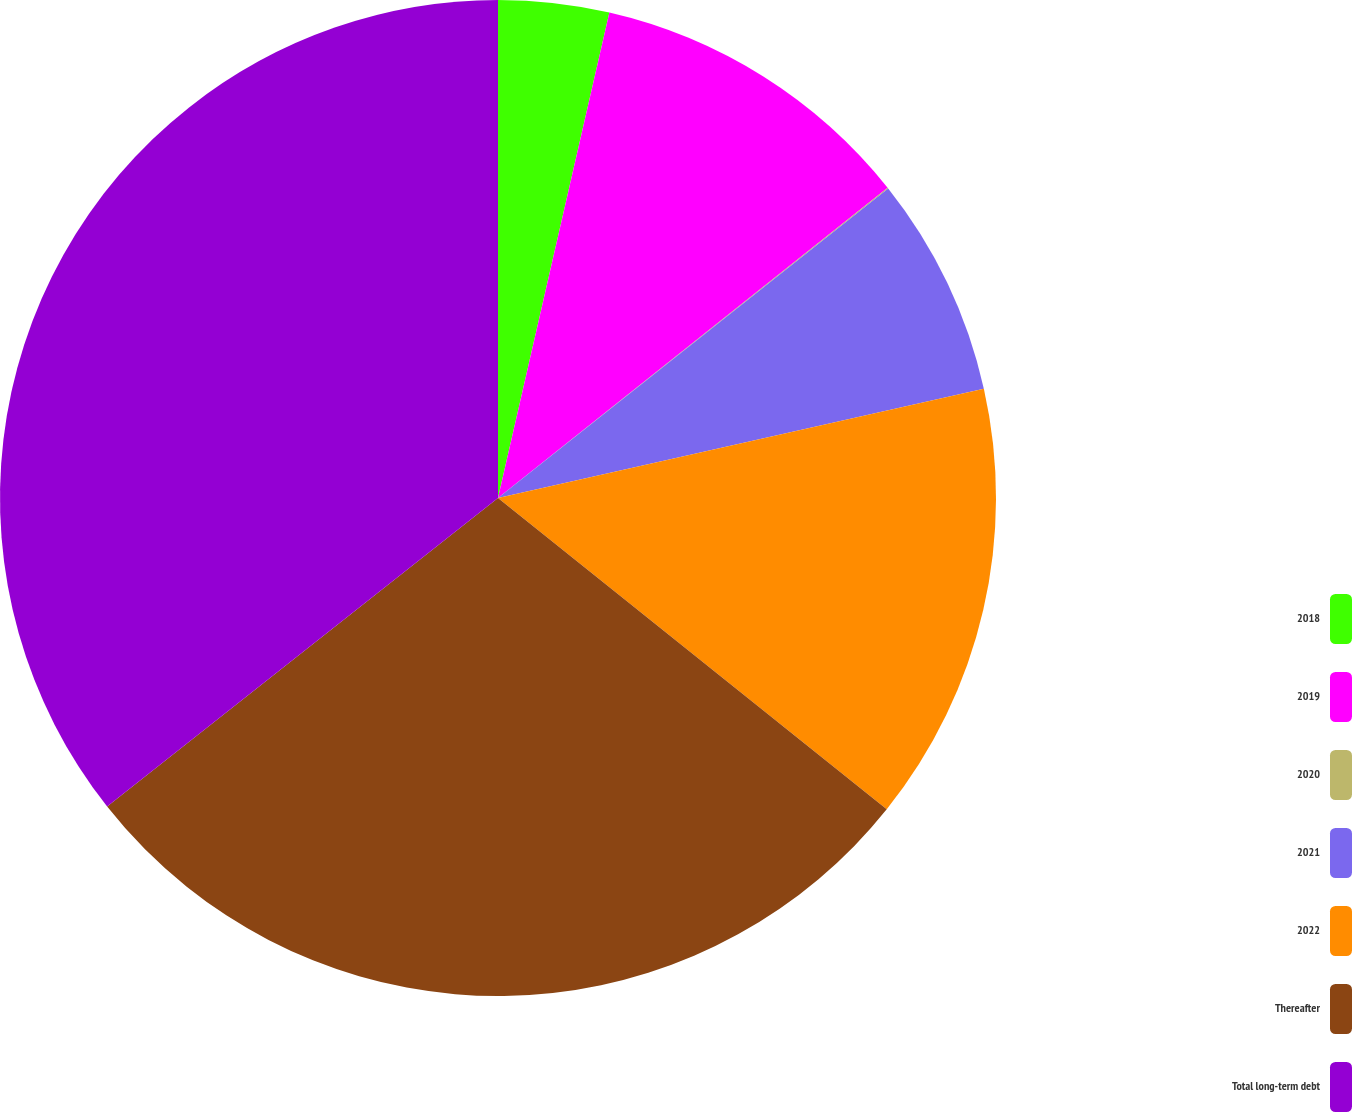Convert chart. <chart><loc_0><loc_0><loc_500><loc_500><pie_chart><fcel>2018<fcel>2019<fcel>2020<fcel>2021<fcel>2022<fcel>Thereafter<fcel>Total long-term debt<nl><fcel>3.59%<fcel>10.71%<fcel>0.03%<fcel>7.15%<fcel>14.27%<fcel>28.62%<fcel>35.64%<nl></chart> 